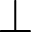Convert formula to latex. <formula><loc_0><loc_0><loc_500><loc_500>\bot</formula> 